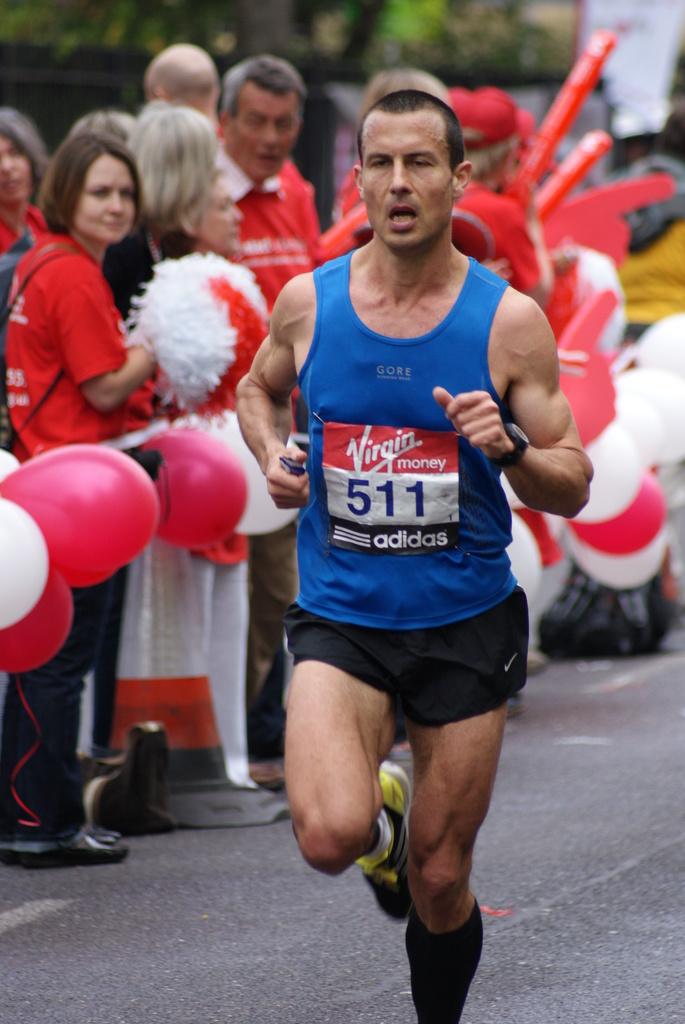What's this runner's tag running number?
Provide a short and direct response. 511. What shoe brand is on the shirt?
Provide a succinct answer. Adidas. 